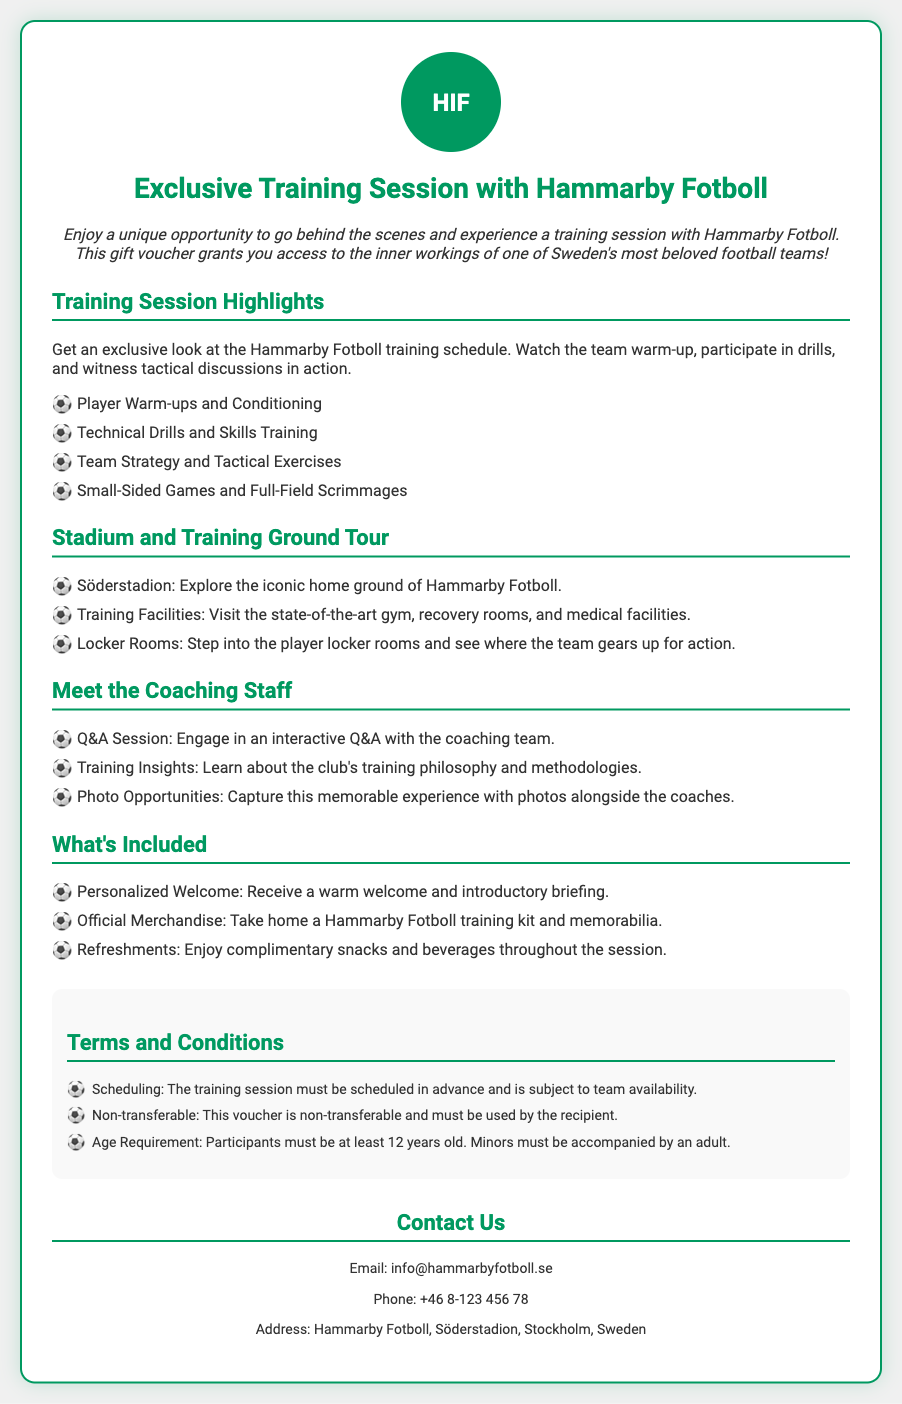what is the title of the voucher? The title of the voucher is prominently displayed at the top of the document and is "Exclusive Training Session with Hammarby Fotboll."
Answer: Exclusive Training Session with Hammarby Fotboll what is included in the training session? The document lists several items that are included and they are official merchandise, personalized welcome, and refreshments.
Answer: Personalized Welcome, Official Merchandise, Refreshments what age must participants be? The age requirement for participants is mentioned in the terms and conditions as being at least 12 years old.
Answer: 12 years old what is the first training highlight? The first item under the training session highlights is about player warm-ups and conditioning.
Answer: Player Warm-ups and Conditioning where is the club located? The document provides an address for Hammarby Fotboll listed at the end of the document.
Answer: Söderstadion, Stockholm, Sweden how can participants meet the coaching staff? The document states that participants can engage in an interactive Q&A with the coaching team to meet them.
Answer: Interactive Q&A what must be scheduled in advance? The document specifies that the training session must be scheduled in advance and is subject to team availability.
Answer: The training session how can participants capture their experience? The document mentions that photo opportunities will be available, allowing participants to capture memorable moments.
Answer: Photo Opportunities what is the contact email for inquiries? The document provides a contact email for Hammarby Fotboll, which is shown in the contact section.
Answer: info@hammarbyfotboll.se 